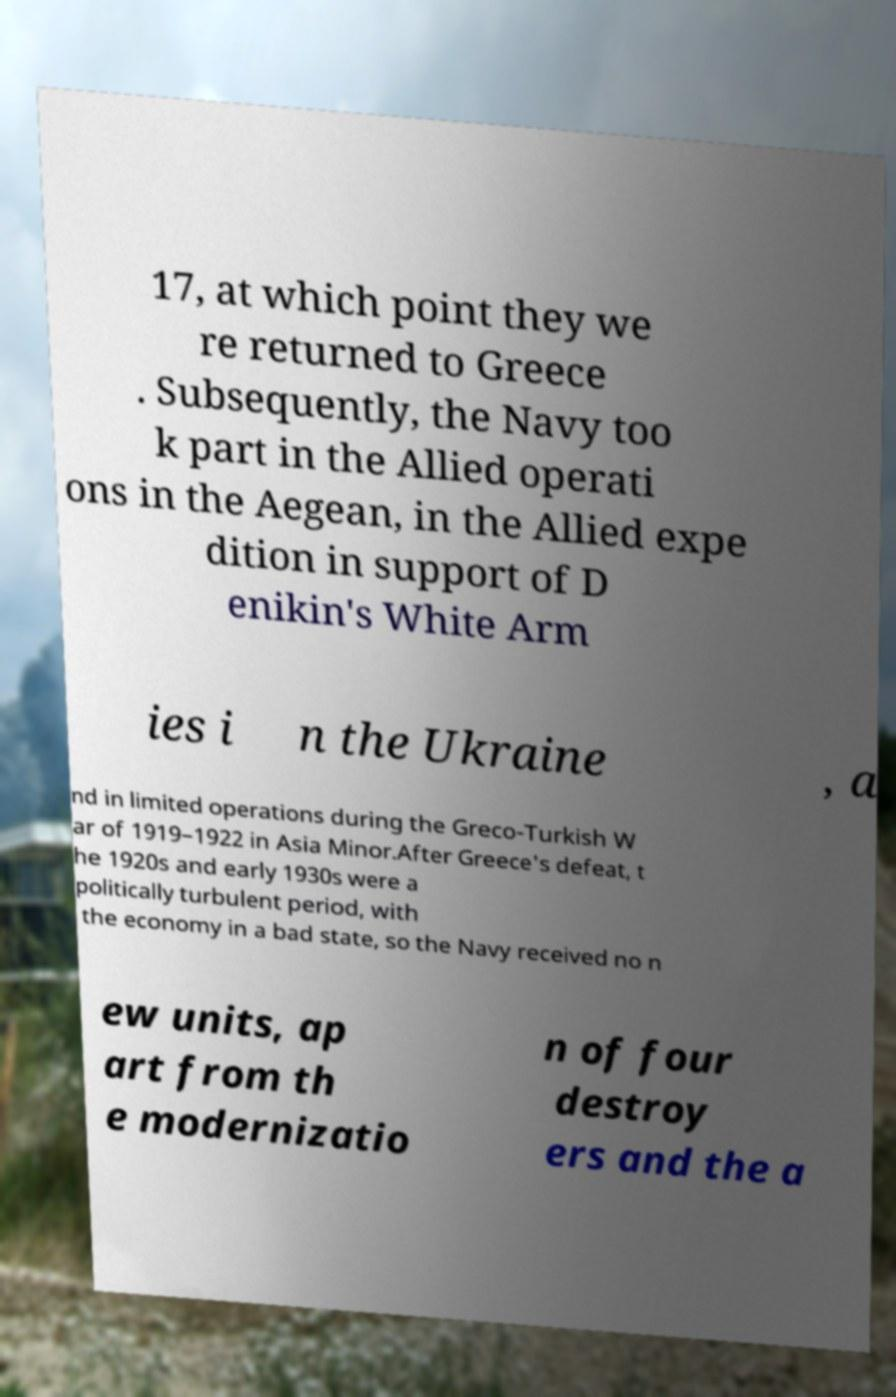There's text embedded in this image that I need extracted. Can you transcribe it verbatim? 17, at which point they we re returned to Greece . Subsequently, the Navy too k part in the Allied operati ons in the Aegean, in the Allied expe dition in support of D enikin's White Arm ies i n the Ukraine , a nd in limited operations during the Greco-Turkish W ar of 1919–1922 in Asia Minor.After Greece's defeat, t he 1920s and early 1930s were a politically turbulent period, with the economy in a bad state, so the Navy received no n ew units, ap art from th e modernizatio n of four destroy ers and the a 